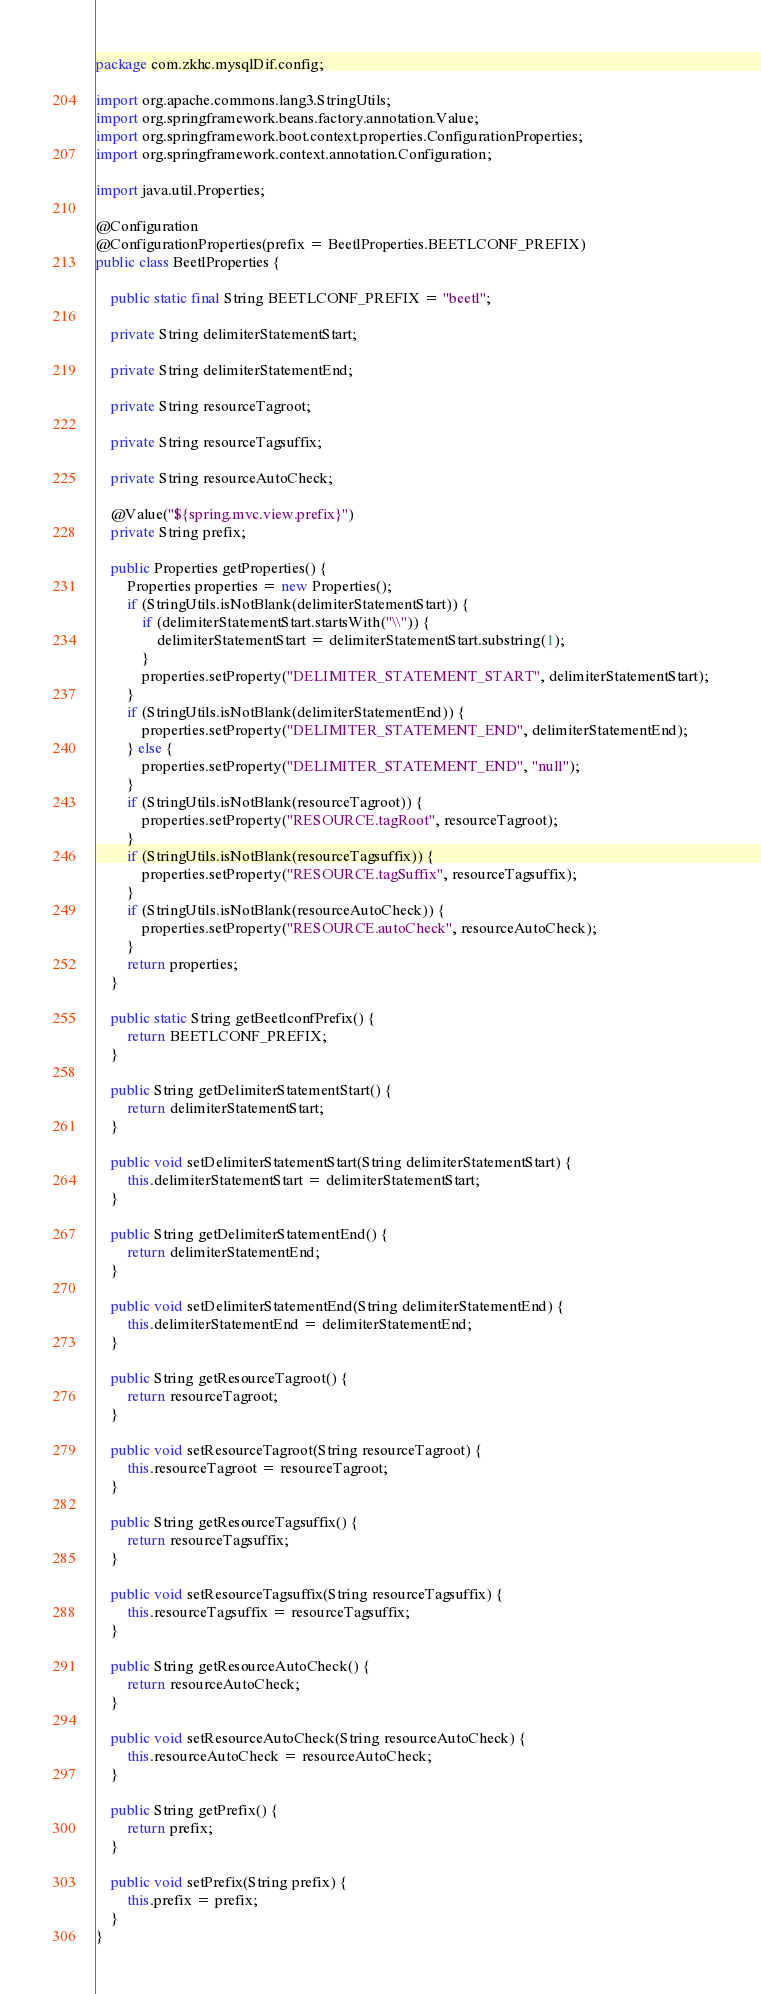Convert code to text. <code><loc_0><loc_0><loc_500><loc_500><_Java_>package com.zkhc.mysqlDif.config;

import org.apache.commons.lang3.StringUtils;
import org.springframework.beans.factory.annotation.Value;
import org.springframework.boot.context.properties.ConfigurationProperties;
import org.springframework.context.annotation.Configuration;

import java.util.Properties;

@Configuration
@ConfigurationProperties(prefix = BeetlProperties.BEETLCONF_PREFIX)
public class BeetlProperties {

    public static final String BEETLCONF_PREFIX = "beetl";

    private String delimiterStatementStart;

    private String delimiterStatementEnd;

    private String resourceTagroot;

    private String resourceTagsuffix;

    private String resourceAutoCheck;

    @Value("${spring.mvc.view.prefix}")
    private String prefix;

    public Properties getProperties() {
        Properties properties = new Properties();
        if (StringUtils.isNotBlank(delimiterStatementStart)) {
            if (delimiterStatementStart.startsWith("\\")) {
                delimiterStatementStart = delimiterStatementStart.substring(1);
            }
            properties.setProperty("DELIMITER_STATEMENT_START", delimiterStatementStart);
        }
        if (StringUtils.isNotBlank(delimiterStatementEnd)) {
            properties.setProperty("DELIMITER_STATEMENT_END", delimiterStatementEnd);
        } else {
            properties.setProperty("DELIMITER_STATEMENT_END", "null");
        }
        if (StringUtils.isNotBlank(resourceTagroot)) {
            properties.setProperty("RESOURCE.tagRoot", resourceTagroot);
        }
        if (StringUtils.isNotBlank(resourceTagsuffix)) {
            properties.setProperty("RESOURCE.tagSuffix", resourceTagsuffix);
        }
        if (StringUtils.isNotBlank(resourceAutoCheck)) {
            properties.setProperty("RESOURCE.autoCheck", resourceAutoCheck);
        }
        return properties;
    }

    public static String getBeetlconfPrefix() {
        return BEETLCONF_PREFIX;
    }

    public String getDelimiterStatementStart() {
        return delimiterStatementStart;
    }

    public void setDelimiterStatementStart(String delimiterStatementStart) {
        this.delimiterStatementStart = delimiterStatementStart;
    }

    public String getDelimiterStatementEnd() {
        return delimiterStatementEnd;
    }

    public void setDelimiterStatementEnd(String delimiterStatementEnd) {
        this.delimiterStatementEnd = delimiterStatementEnd;
    }

    public String getResourceTagroot() {
        return resourceTagroot;
    }

    public void setResourceTagroot(String resourceTagroot) {
        this.resourceTagroot = resourceTagroot;
    }

    public String getResourceTagsuffix() {
        return resourceTagsuffix;
    }

    public void setResourceTagsuffix(String resourceTagsuffix) {
        this.resourceTagsuffix = resourceTagsuffix;
    }

    public String getResourceAutoCheck() {
        return resourceAutoCheck;
    }

    public void setResourceAutoCheck(String resourceAutoCheck) {
        this.resourceAutoCheck = resourceAutoCheck;
    }

    public String getPrefix() {
        return prefix;
    }

    public void setPrefix(String prefix) {
        this.prefix = prefix;
    }
}

</code> 